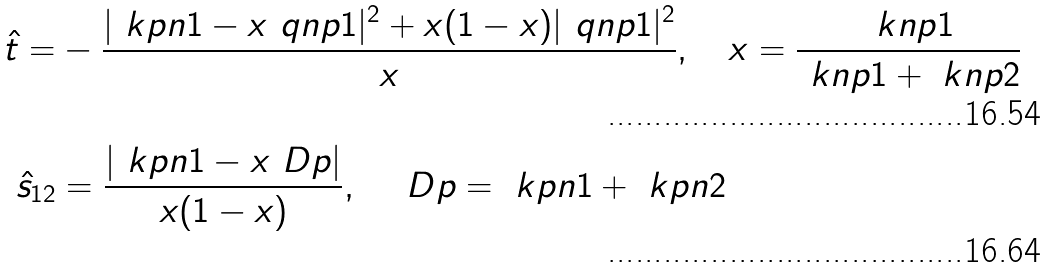<formula> <loc_0><loc_0><loc_500><loc_500>\hat { t } = & - \frac { | \ k p n 1 - x \ q n p 1 | ^ { 2 } + x ( 1 - x ) | \ q n p 1 | ^ { 2 } } { x } , \quad x = \frac { \ k n p 1 } { \ k n p 1 + \ k n p 2 } \\ \hat { s } _ { 1 2 } & = \frac { \left | \ k p n 1 - x \ D p \right | } { x ( 1 - x ) } , \quad \ D p = \ k p n 1 + \ k p n 2</formula> 